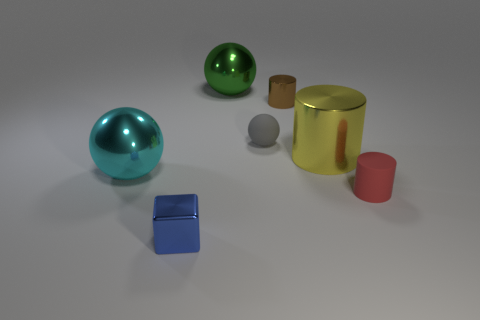Add 2 big cyan shiny things. How many objects exist? 9 Subtract all cubes. How many objects are left? 6 Subtract all tiny metallic cubes. Subtract all small blue objects. How many objects are left? 5 Add 1 blue metallic objects. How many blue metallic objects are left? 2 Add 1 purple shiny cylinders. How many purple shiny cylinders exist? 1 Subtract 1 green balls. How many objects are left? 6 